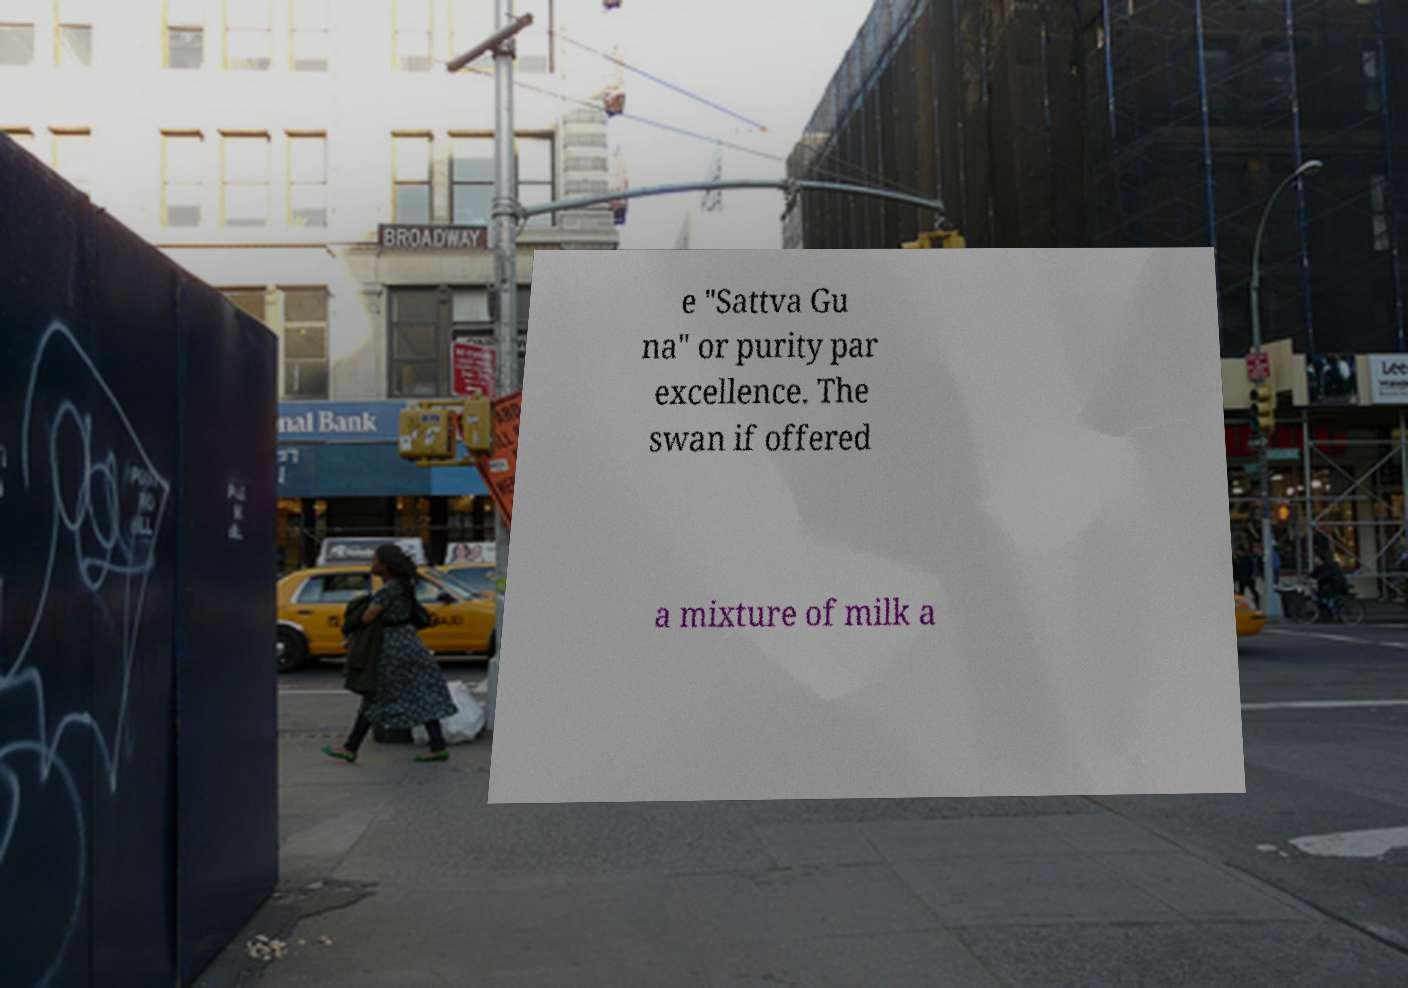What messages or text are displayed in this image? I need them in a readable, typed format. e "Sattva Gu na" or purity par excellence. The swan if offered a mixture of milk a 